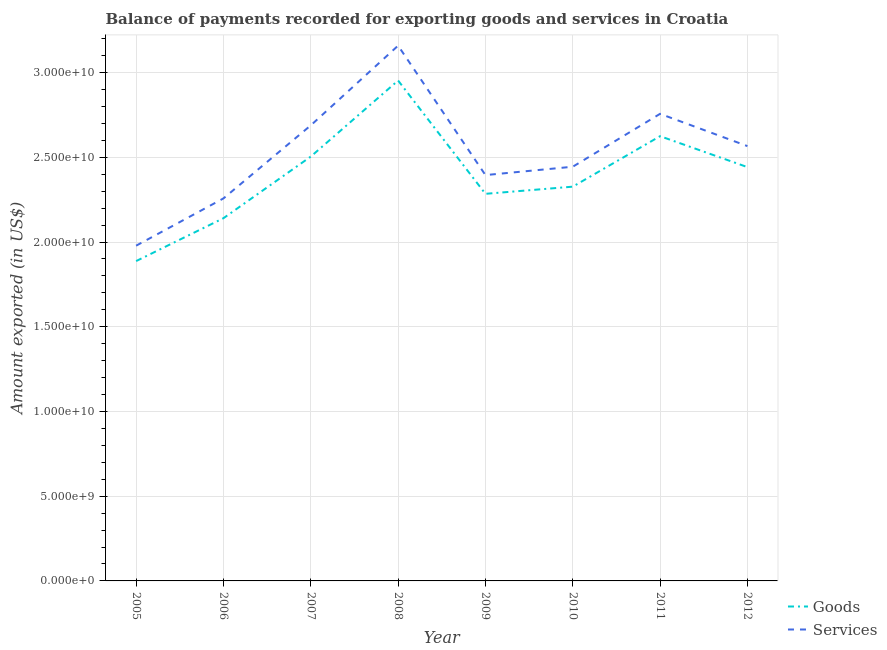How many different coloured lines are there?
Give a very brief answer. 2. Is the number of lines equal to the number of legend labels?
Your response must be concise. Yes. What is the amount of goods exported in 2007?
Provide a short and direct response. 2.50e+1. Across all years, what is the maximum amount of goods exported?
Your response must be concise. 2.95e+1. Across all years, what is the minimum amount of services exported?
Keep it short and to the point. 1.98e+1. In which year was the amount of services exported minimum?
Ensure brevity in your answer.  2005. What is the total amount of goods exported in the graph?
Give a very brief answer. 1.92e+11. What is the difference between the amount of services exported in 2005 and that in 2010?
Offer a terse response. -4.66e+09. What is the difference between the amount of services exported in 2011 and the amount of goods exported in 2005?
Your answer should be very brief. 8.69e+09. What is the average amount of services exported per year?
Your response must be concise. 2.53e+1. In the year 2007, what is the difference between the amount of services exported and amount of goods exported?
Provide a short and direct response. 1.84e+09. In how many years, is the amount of goods exported greater than 31000000000 US$?
Keep it short and to the point. 0. What is the ratio of the amount of goods exported in 2005 to that in 2009?
Provide a succinct answer. 0.83. Is the amount of goods exported in 2008 less than that in 2009?
Keep it short and to the point. No. Is the difference between the amount of services exported in 2011 and 2012 greater than the difference between the amount of goods exported in 2011 and 2012?
Your response must be concise. Yes. What is the difference between the highest and the second highest amount of goods exported?
Provide a succinct answer. 3.28e+09. What is the difference between the highest and the lowest amount of services exported?
Provide a short and direct response. 1.18e+1. Is the sum of the amount of services exported in 2008 and 2009 greater than the maximum amount of goods exported across all years?
Offer a terse response. Yes. Is the amount of services exported strictly greater than the amount of goods exported over the years?
Provide a succinct answer. Yes. How many lines are there?
Your answer should be compact. 2. What is the difference between two consecutive major ticks on the Y-axis?
Give a very brief answer. 5.00e+09. Does the graph contain any zero values?
Offer a very short reply. No. Where does the legend appear in the graph?
Make the answer very short. Bottom right. What is the title of the graph?
Offer a very short reply. Balance of payments recorded for exporting goods and services in Croatia. Does "Registered firms" appear as one of the legend labels in the graph?
Provide a succinct answer. No. What is the label or title of the X-axis?
Provide a short and direct response. Year. What is the label or title of the Y-axis?
Ensure brevity in your answer.  Amount exported (in US$). What is the Amount exported (in US$) of Goods in 2005?
Make the answer very short. 1.89e+1. What is the Amount exported (in US$) of Services in 2005?
Make the answer very short. 1.98e+1. What is the Amount exported (in US$) in Goods in 2006?
Offer a very short reply. 2.14e+1. What is the Amount exported (in US$) in Services in 2006?
Provide a succinct answer. 2.26e+1. What is the Amount exported (in US$) of Goods in 2007?
Offer a very short reply. 2.50e+1. What is the Amount exported (in US$) in Services in 2007?
Give a very brief answer. 2.69e+1. What is the Amount exported (in US$) in Goods in 2008?
Provide a succinct answer. 2.95e+1. What is the Amount exported (in US$) of Services in 2008?
Offer a very short reply. 3.16e+1. What is the Amount exported (in US$) of Goods in 2009?
Keep it short and to the point. 2.28e+1. What is the Amount exported (in US$) of Services in 2009?
Provide a succinct answer. 2.40e+1. What is the Amount exported (in US$) in Goods in 2010?
Keep it short and to the point. 2.33e+1. What is the Amount exported (in US$) of Services in 2010?
Your answer should be very brief. 2.44e+1. What is the Amount exported (in US$) in Goods in 2011?
Keep it short and to the point. 2.62e+1. What is the Amount exported (in US$) in Services in 2011?
Your response must be concise. 2.76e+1. What is the Amount exported (in US$) of Goods in 2012?
Give a very brief answer. 2.44e+1. What is the Amount exported (in US$) of Services in 2012?
Your response must be concise. 2.57e+1. Across all years, what is the maximum Amount exported (in US$) in Goods?
Provide a short and direct response. 2.95e+1. Across all years, what is the maximum Amount exported (in US$) of Services?
Provide a succinct answer. 3.16e+1. Across all years, what is the minimum Amount exported (in US$) in Goods?
Provide a short and direct response. 1.89e+1. Across all years, what is the minimum Amount exported (in US$) of Services?
Offer a very short reply. 1.98e+1. What is the total Amount exported (in US$) of Goods in the graph?
Ensure brevity in your answer.  1.92e+11. What is the total Amount exported (in US$) in Services in the graph?
Keep it short and to the point. 2.02e+11. What is the difference between the Amount exported (in US$) in Goods in 2005 and that in 2006?
Provide a succinct answer. -2.53e+09. What is the difference between the Amount exported (in US$) of Services in 2005 and that in 2006?
Give a very brief answer. -2.79e+09. What is the difference between the Amount exported (in US$) of Goods in 2005 and that in 2007?
Make the answer very short. -6.17e+09. What is the difference between the Amount exported (in US$) of Services in 2005 and that in 2007?
Your answer should be compact. -7.10e+09. What is the difference between the Amount exported (in US$) in Goods in 2005 and that in 2008?
Ensure brevity in your answer.  -1.07e+1. What is the difference between the Amount exported (in US$) in Services in 2005 and that in 2008?
Give a very brief answer. -1.18e+1. What is the difference between the Amount exported (in US$) of Goods in 2005 and that in 2009?
Your answer should be very brief. -3.97e+09. What is the difference between the Amount exported (in US$) of Services in 2005 and that in 2009?
Make the answer very short. -4.17e+09. What is the difference between the Amount exported (in US$) of Goods in 2005 and that in 2010?
Your answer should be compact. -4.39e+09. What is the difference between the Amount exported (in US$) of Services in 2005 and that in 2010?
Offer a very short reply. -4.66e+09. What is the difference between the Amount exported (in US$) in Goods in 2005 and that in 2011?
Make the answer very short. -7.37e+09. What is the difference between the Amount exported (in US$) in Services in 2005 and that in 2011?
Your answer should be compact. -7.78e+09. What is the difference between the Amount exported (in US$) of Goods in 2005 and that in 2012?
Your answer should be compact. -5.55e+09. What is the difference between the Amount exported (in US$) of Services in 2005 and that in 2012?
Make the answer very short. -5.88e+09. What is the difference between the Amount exported (in US$) of Goods in 2006 and that in 2007?
Ensure brevity in your answer.  -3.64e+09. What is the difference between the Amount exported (in US$) in Services in 2006 and that in 2007?
Give a very brief answer. -4.31e+09. What is the difference between the Amount exported (in US$) of Goods in 2006 and that in 2008?
Offer a very short reply. -8.13e+09. What is the difference between the Amount exported (in US$) in Services in 2006 and that in 2008?
Make the answer very short. -9.02e+09. What is the difference between the Amount exported (in US$) of Goods in 2006 and that in 2009?
Your answer should be compact. -1.44e+09. What is the difference between the Amount exported (in US$) in Services in 2006 and that in 2009?
Offer a very short reply. -1.38e+09. What is the difference between the Amount exported (in US$) of Goods in 2006 and that in 2010?
Ensure brevity in your answer.  -1.86e+09. What is the difference between the Amount exported (in US$) of Services in 2006 and that in 2010?
Your answer should be compact. -1.87e+09. What is the difference between the Amount exported (in US$) of Goods in 2006 and that in 2011?
Your answer should be very brief. -4.84e+09. What is the difference between the Amount exported (in US$) of Services in 2006 and that in 2011?
Make the answer very short. -4.99e+09. What is the difference between the Amount exported (in US$) in Goods in 2006 and that in 2012?
Your answer should be compact. -3.02e+09. What is the difference between the Amount exported (in US$) of Services in 2006 and that in 2012?
Keep it short and to the point. -3.09e+09. What is the difference between the Amount exported (in US$) in Goods in 2007 and that in 2008?
Give a very brief answer. -4.49e+09. What is the difference between the Amount exported (in US$) of Services in 2007 and that in 2008?
Keep it short and to the point. -4.71e+09. What is the difference between the Amount exported (in US$) of Goods in 2007 and that in 2009?
Provide a short and direct response. 2.20e+09. What is the difference between the Amount exported (in US$) in Services in 2007 and that in 2009?
Give a very brief answer. 2.93e+09. What is the difference between the Amount exported (in US$) in Goods in 2007 and that in 2010?
Give a very brief answer. 1.78e+09. What is the difference between the Amount exported (in US$) of Services in 2007 and that in 2010?
Provide a succinct answer. 2.44e+09. What is the difference between the Amount exported (in US$) in Goods in 2007 and that in 2011?
Your response must be concise. -1.20e+09. What is the difference between the Amount exported (in US$) in Services in 2007 and that in 2011?
Ensure brevity in your answer.  -6.82e+08. What is the difference between the Amount exported (in US$) in Goods in 2007 and that in 2012?
Make the answer very short. 6.22e+08. What is the difference between the Amount exported (in US$) of Services in 2007 and that in 2012?
Keep it short and to the point. 1.22e+09. What is the difference between the Amount exported (in US$) in Goods in 2008 and that in 2009?
Your answer should be compact. 6.69e+09. What is the difference between the Amount exported (in US$) of Services in 2008 and that in 2009?
Your answer should be very brief. 7.64e+09. What is the difference between the Amount exported (in US$) in Goods in 2008 and that in 2010?
Your answer should be very brief. 6.26e+09. What is the difference between the Amount exported (in US$) in Services in 2008 and that in 2010?
Make the answer very short. 7.15e+09. What is the difference between the Amount exported (in US$) of Goods in 2008 and that in 2011?
Give a very brief answer. 3.28e+09. What is the difference between the Amount exported (in US$) of Services in 2008 and that in 2011?
Your answer should be very brief. 4.02e+09. What is the difference between the Amount exported (in US$) of Goods in 2008 and that in 2012?
Make the answer very short. 5.11e+09. What is the difference between the Amount exported (in US$) of Services in 2008 and that in 2012?
Your response must be concise. 5.93e+09. What is the difference between the Amount exported (in US$) of Goods in 2009 and that in 2010?
Offer a very short reply. -4.22e+08. What is the difference between the Amount exported (in US$) in Services in 2009 and that in 2010?
Offer a terse response. -4.93e+08. What is the difference between the Amount exported (in US$) of Goods in 2009 and that in 2011?
Give a very brief answer. -3.40e+09. What is the difference between the Amount exported (in US$) of Services in 2009 and that in 2011?
Make the answer very short. -3.62e+09. What is the difference between the Amount exported (in US$) in Goods in 2009 and that in 2012?
Provide a succinct answer. -1.58e+09. What is the difference between the Amount exported (in US$) in Services in 2009 and that in 2012?
Make the answer very short. -1.71e+09. What is the difference between the Amount exported (in US$) of Goods in 2010 and that in 2011?
Offer a very short reply. -2.98e+09. What is the difference between the Amount exported (in US$) in Services in 2010 and that in 2011?
Provide a succinct answer. -3.12e+09. What is the difference between the Amount exported (in US$) in Goods in 2010 and that in 2012?
Keep it short and to the point. -1.15e+09. What is the difference between the Amount exported (in US$) of Services in 2010 and that in 2012?
Make the answer very short. -1.22e+09. What is the difference between the Amount exported (in US$) in Goods in 2011 and that in 2012?
Provide a short and direct response. 1.83e+09. What is the difference between the Amount exported (in US$) in Services in 2011 and that in 2012?
Make the answer very short. 1.90e+09. What is the difference between the Amount exported (in US$) of Goods in 2005 and the Amount exported (in US$) of Services in 2006?
Your answer should be very brief. -3.70e+09. What is the difference between the Amount exported (in US$) in Goods in 2005 and the Amount exported (in US$) in Services in 2007?
Your answer should be compact. -8.01e+09. What is the difference between the Amount exported (in US$) in Goods in 2005 and the Amount exported (in US$) in Services in 2008?
Offer a very short reply. -1.27e+1. What is the difference between the Amount exported (in US$) in Goods in 2005 and the Amount exported (in US$) in Services in 2009?
Provide a short and direct response. -5.08e+09. What is the difference between the Amount exported (in US$) of Goods in 2005 and the Amount exported (in US$) of Services in 2010?
Make the answer very short. -5.57e+09. What is the difference between the Amount exported (in US$) in Goods in 2005 and the Amount exported (in US$) in Services in 2011?
Provide a succinct answer. -8.69e+09. What is the difference between the Amount exported (in US$) in Goods in 2005 and the Amount exported (in US$) in Services in 2012?
Your answer should be very brief. -6.79e+09. What is the difference between the Amount exported (in US$) of Goods in 2006 and the Amount exported (in US$) of Services in 2007?
Offer a terse response. -5.48e+09. What is the difference between the Amount exported (in US$) in Goods in 2006 and the Amount exported (in US$) in Services in 2008?
Make the answer very short. -1.02e+1. What is the difference between the Amount exported (in US$) of Goods in 2006 and the Amount exported (in US$) of Services in 2009?
Give a very brief answer. -2.55e+09. What is the difference between the Amount exported (in US$) of Goods in 2006 and the Amount exported (in US$) of Services in 2010?
Keep it short and to the point. -3.04e+09. What is the difference between the Amount exported (in US$) of Goods in 2006 and the Amount exported (in US$) of Services in 2011?
Offer a very short reply. -6.16e+09. What is the difference between the Amount exported (in US$) in Goods in 2006 and the Amount exported (in US$) in Services in 2012?
Your answer should be compact. -4.26e+09. What is the difference between the Amount exported (in US$) of Goods in 2007 and the Amount exported (in US$) of Services in 2008?
Provide a succinct answer. -6.55e+09. What is the difference between the Amount exported (in US$) of Goods in 2007 and the Amount exported (in US$) of Services in 2009?
Keep it short and to the point. 1.09e+09. What is the difference between the Amount exported (in US$) in Goods in 2007 and the Amount exported (in US$) in Services in 2010?
Keep it short and to the point. 5.99e+08. What is the difference between the Amount exported (in US$) of Goods in 2007 and the Amount exported (in US$) of Services in 2011?
Your answer should be very brief. -2.52e+09. What is the difference between the Amount exported (in US$) of Goods in 2007 and the Amount exported (in US$) of Services in 2012?
Keep it short and to the point. -6.19e+08. What is the difference between the Amount exported (in US$) of Goods in 2008 and the Amount exported (in US$) of Services in 2009?
Make the answer very short. 5.58e+09. What is the difference between the Amount exported (in US$) of Goods in 2008 and the Amount exported (in US$) of Services in 2010?
Make the answer very short. 5.09e+09. What is the difference between the Amount exported (in US$) of Goods in 2008 and the Amount exported (in US$) of Services in 2011?
Your response must be concise. 1.96e+09. What is the difference between the Amount exported (in US$) of Goods in 2008 and the Amount exported (in US$) of Services in 2012?
Provide a succinct answer. 3.87e+09. What is the difference between the Amount exported (in US$) in Goods in 2009 and the Amount exported (in US$) in Services in 2010?
Provide a succinct answer. -1.60e+09. What is the difference between the Amount exported (in US$) in Goods in 2009 and the Amount exported (in US$) in Services in 2011?
Keep it short and to the point. -4.72e+09. What is the difference between the Amount exported (in US$) of Goods in 2009 and the Amount exported (in US$) of Services in 2012?
Offer a very short reply. -2.82e+09. What is the difference between the Amount exported (in US$) in Goods in 2010 and the Amount exported (in US$) in Services in 2011?
Provide a short and direct response. -4.30e+09. What is the difference between the Amount exported (in US$) in Goods in 2010 and the Amount exported (in US$) in Services in 2012?
Offer a terse response. -2.39e+09. What is the difference between the Amount exported (in US$) in Goods in 2011 and the Amount exported (in US$) in Services in 2012?
Keep it short and to the point. 5.85e+08. What is the average Amount exported (in US$) in Goods per year?
Give a very brief answer. 2.40e+1. What is the average Amount exported (in US$) in Services per year?
Your answer should be very brief. 2.53e+1. In the year 2005, what is the difference between the Amount exported (in US$) of Goods and Amount exported (in US$) of Services?
Your response must be concise. -9.09e+08. In the year 2006, what is the difference between the Amount exported (in US$) of Goods and Amount exported (in US$) of Services?
Keep it short and to the point. -1.17e+09. In the year 2007, what is the difference between the Amount exported (in US$) in Goods and Amount exported (in US$) in Services?
Make the answer very short. -1.84e+09. In the year 2008, what is the difference between the Amount exported (in US$) of Goods and Amount exported (in US$) of Services?
Ensure brevity in your answer.  -2.06e+09. In the year 2009, what is the difference between the Amount exported (in US$) of Goods and Amount exported (in US$) of Services?
Provide a succinct answer. -1.11e+09. In the year 2010, what is the difference between the Amount exported (in US$) in Goods and Amount exported (in US$) in Services?
Ensure brevity in your answer.  -1.18e+09. In the year 2011, what is the difference between the Amount exported (in US$) in Goods and Amount exported (in US$) in Services?
Provide a succinct answer. -1.32e+09. In the year 2012, what is the difference between the Amount exported (in US$) in Goods and Amount exported (in US$) in Services?
Your response must be concise. -1.24e+09. What is the ratio of the Amount exported (in US$) in Goods in 2005 to that in 2006?
Your answer should be compact. 0.88. What is the ratio of the Amount exported (in US$) in Services in 2005 to that in 2006?
Offer a very short reply. 0.88. What is the ratio of the Amount exported (in US$) in Goods in 2005 to that in 2007?
Ensure brevity in your answer.  0.75. What is the ratio of the Amount exported (in US$) in Services in 2005 to that in 2007?
Offer a terse response. 0.74. What is the ratio of the Amount exported (in US$) of Goods in 2005 to that in 2008?
Provide a short and direct response. 0.64. What is the ratio of the Amount exported (in US$) of Services in 2005 to that in 2008?
Your answer should be compact. 0.63. What is the ratio of the Amount exported (in US$) of Goods in 2005 to that in 2009?
Your answer should be compact. 0.83. What is the ratio of the Amount exported (in US$) in Services in 2005 to that in 2009?
Ensure brevity in your answer.  0.83. What is the ratio of the Amount exported (in US$) of Goods in 2005 to that in 2010?
Provide a succinct answer. 0.81. What is the ratio of the Amount exported (in US$) in Services in 2005 to that in 2010?
Provide a short and direct response. 0.81. What is the ratio of the Amount exported (in US$) of Goods in 2005 to that in 2011?
Provide a succinct answer. 0.72. What is the ratio of the Amount exported (in US$) of Services in 2005 to that in 2011?
Ensure brevity in your answer.  0.72. What is the ratio of the Amount exported (in US$) of Goods in 2005 to that in 2012?
Your response must be concise. 0.77. What is the ratio of the Amount exported (in US$) in Services in 2005 to that in 2012?
Provide a short and direct response. 0.77. What is the ratio of the Amount exported (in US$) of Goods in 2006 to that in 2007?
Keep it short and to the point. 0.85. What is the ratio of the Amount exported (in US$) in Services in 2006 to that in 2007?
Ensure brevity in your answer.  0.84. What is the ratio of the Amount exported (in US$) in Goods in 2006 to that in 2008?
Ensure brevity in your answer.  0.72. What is the ratio of the Amount exported (in US$) of Services in 2006 to that in 2008?
Your answer should be very brief. 0.71. What is the ratio of the Amount exported (in US$) of Goods in 2006 to that in 2009?
Make the answer very short. 0.94. What is the ratio of the Amount exported (in US$) of Services in 2006 to that in 2009?
Make the answer very short. 0.94. What is the ratio of the Amount exported (in US$) in Goods in 2006 to that in 2010?
Provide a succinct answer. 0.92. What is the ratio of the Amount exported (in US$) in Services in 2006 to that in 2010?
Your answer should be very brief. 0.92. What is the ratio of the Amount exported (in US$) of Goods in 2006 to that in 2011?
Your answer should be very brief. 0.82. What is the ratio of the Amount exported (in US$) of Services in 2006 to that in 2011?
Make the answer very short. 0.82. What is the ratio of the Amount exported (in US$) in Goods in 2006 to that in 2012?
Provide a succinct answer. 0.88. What is the ratio of the Amount exported (in US$) in Services in 2006 to that in 2012?
Keep it short and to the point. 0.88. What is the ratio of the Amount exported (in US$) in Goods in 2007 to that in 2008?
Provide a short and direct response. 0.85. What is the ratio of the Amount exported (in US$) of Services in 2007 to that in 2008?
Give a very brief answer. 0.85. What is the ratio of the Amount exported (in US$) in Goods in 2007 to that in 2009?
Provide a succinct answer. 1.1. What is the ratio of the Amount exported (in US$) of Services in 2007 to that in 2009?
Offer a terse response. 1.12. What is the ratio of the Amount exported (in US$) in Goods in 2007 to that in 2010?
Provide a succinct answer. 1.08. What is the ratio of the Amount exported (in US$) of Services in 2007 to that in 2010?
Provide a succinct answer. 1.1. What is the ratio of the Amount exported (in US$) in Goods in 2007 to that in 2011?
Your response must be concise. 0.95. What is the ratio of the Amount exported (in US$) of Services in 2007 to that in 2011?
Provide a succinct answer. 0.98. What is the ratio of the Amount exported (in US$) in Goods in 2007 to that in 2012?
Provide a short and direct response. 1.03. What is the ratio of the Amount exported (in US$) in Services in 2007 to that in 2012?
Your answer should be very brief. 1.05. What is the ratio of the Amount exported (in US$) in Goods in 2008 to that in 2009?
Keep it short and to the point. 1.29. What is the ratio of the Amount exported (in US$) in Services in 2008 to that in 2009?
Offer a very short reply. 1.32. What is the ratio of the Amount exported (in US$) of Goods in 2008 to that in 2010?
Your answer should be very brief. 1.27. What is the ratio of the Amount exported (in US$) in Services in 2008 to that in 2010?
Your response must be concise. 1.29. What is the ratio of the Amount exported (in US$) of Goods in 2008 to that in 2011?
Give a very brief answer. 1.13. What is the ratio of the Amount exported (in US$) of Services in 2008 to that in 2011?
Provide a short and direct response. 1.15. What is the ratio of the Amount exported (in US$) of Goods in 2008 to that in 2012?
Your answer should be very brief. 1.21. What is the ratio of the Amount exported (in US$) in Services in 2008 to that in 2012?
Provide a succinct answer. 1.23. What is the ratio of the Amount exported (in US$) in Goods in 2009 to that in 2010?
Your answer should be very brief. 0.98. What is the ratio of the Amount exported (in US$) in Services in 2009 to that in 2010?
Offer a very short reply. 0.98. What is the ratio of the Amount exported (in US$) of Goods in 2009 to that in 2011?
Provide a succinct answer. 0.87. What is the ratio of the Amount exported (in US$) of Services in 2009 to that in 2011?
Make the answer very short. 0.87. What is the ratio of the Amount exported (in US$) in Goods in 2009 to that in 2012?
Your answer should be very brief. 0.94. What is the ratio of the Amount exported (in US$) in Services in 2009 to that in 2012?
Offer a very short reply. 0.93. What is the ratio of the Amount exported (in US$) in Goods in 2010 to that in 2011?
Your answer should be compact. 0.89. What is the ratio of the Amount exported (in US$) of Services in 2010 to that in 2011?
Your response must be concise. 0.89. What is the ratio of the Amount exported (in US$) in Goods in 2010 to that in 2012?
Ensure brevity in your answer.  0.95. What is the ratio of the Amount exported (in US$) of Services in 2010 to that in 2012?
Offer a very short reply. 0.95. What is the ratio of the Amount exported (in US$) in Goods in 2011 to that in 2012?
Your answer should be very brief. 1.07. What is the ratio of the Amount exported (in US$) of Services in 2011 to that in 2012?
Your response must be concise. 1.07. What is the difference between the highest and the second highest Amount exported (in US$) of Goods?
Offer a very short reply. 3.28e+09. What is the difference between the highest and the second highest Amount exported (in US$) of Services?
Offer a terse response. 4.02e+09. What is the difference between the highest and the lowest Amount exported (in US$) in Goods?
Your answer should be compact. 1.07e+1. What is the difference between the highest and the lowest Amount exported (in US$) in Services?
Make the answer very short. 1.18e+1. 